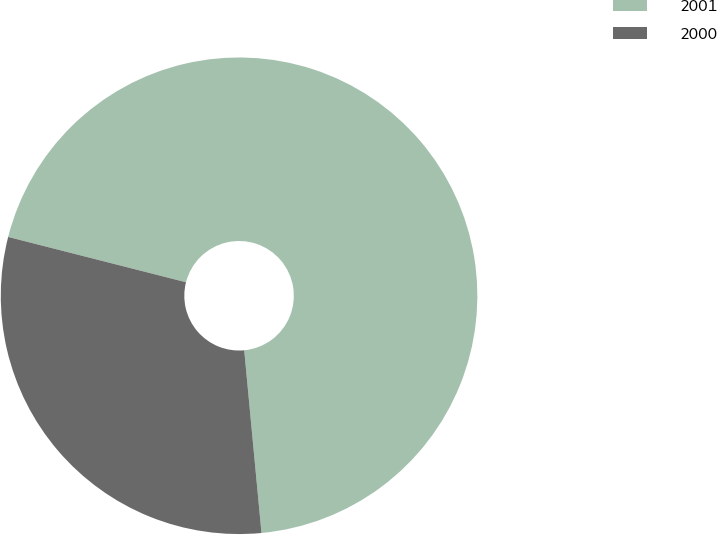Convert chart to OTSL. <chart><loc_0><loc_0><loc_500><loc_500><pie_chart><fcel>2001<fcel>2000<nl><fcel>69.53%<fcel>30.47%<nl></chart> 